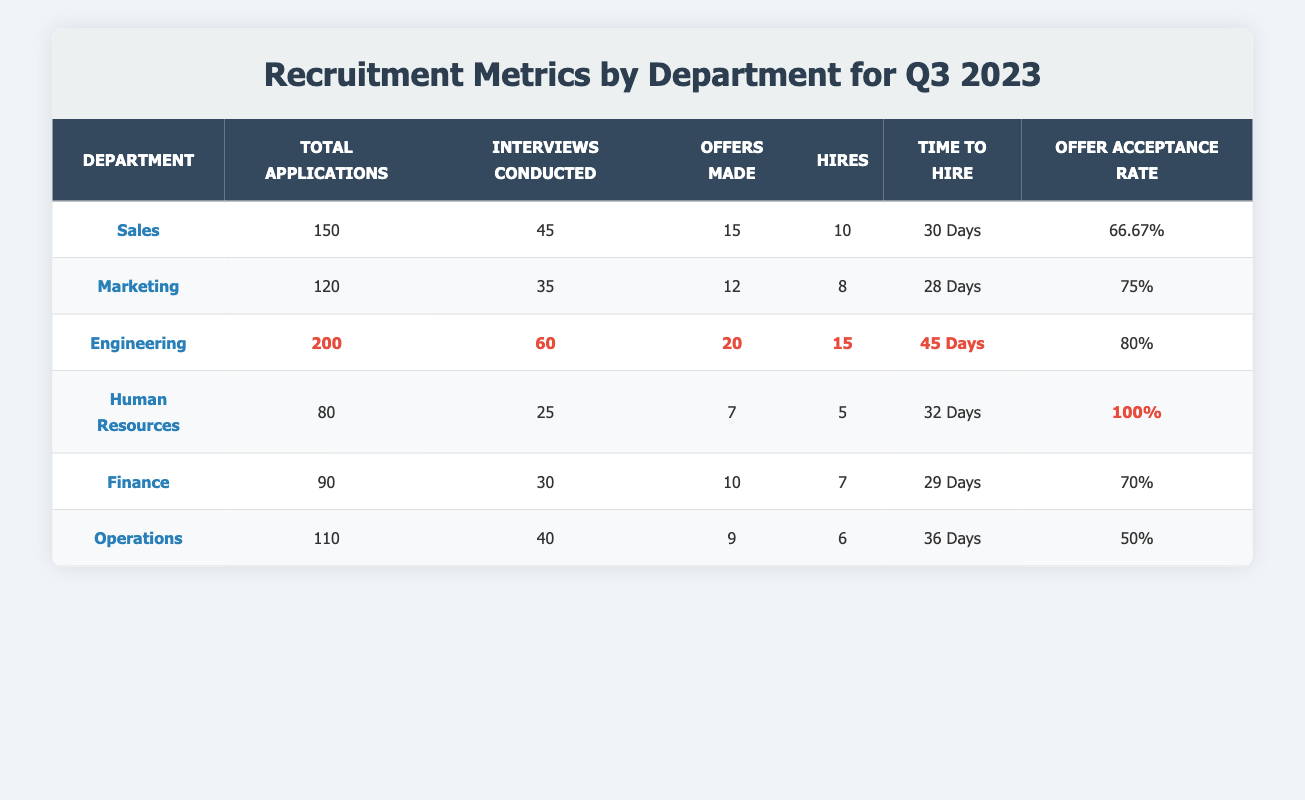What department had the highest number of total applications? Looking at the "Total Applications" column, Engineering has the highest value at 200.
Answer: Engineering What is the offer acceptance rate for the Human Resources department? The table shows that Human Resources has an "Offer Acceptance Rate" of 100%.
Answer: 100% How many hires were made in the Marketing department? The "Hires" column indicates that Marketing made 8 hires.
Answer: 8 What is the average time to hire across all departments? Adding the time to hire for each department: 30 + 28 + 45 + 32 + 29 + 36 = 200. There are 6 departments, so the average is 200/6 = 33.33 Days.
Answer: 33.33 Days Which department conducted the fewest interviews? The "Interviews Conducted" column shows that Human Resources conducted the fewest interviews at 25.
Answer: Human Resources What is the difference in the number of hires between the Sales and Finance departments? Sales made 10 hires and Finance made 7, so the difference is 10 - 7 = 3.
Answer: 3 Is the offer acceptance rate for Operations higher than that of Sales? Operations has an "Offer Acceptance Rate" of 50%, while Sales has 66.67%, so no, Operations is not higher.
Answer: No Which department has the highest rate of offers made per total applications? First, calculate the offer rate for each department: Sales (15/150 = 10%), Marketing (12/120 = 10%), Engineering (20/200 = 10%), HR (7/80 = 8.75%), Finance (10/90 = 11.11%), Operations (9/110 = 8.18%). The highest is Finance at 11.11%.
Answer: Finance What is the total number of hires made in the Engineering and Operations departments combined? Adding the hires from Engineering (15) and Operations (6) gives 15 + 6 = 21.
Answer: 21 Did the Marketing department conduct more interviews than the Operations department? The table shows Marketing conducted 35 interviews, while Operations conducted 40, so Marketing did not conduct more.
Answer: No 